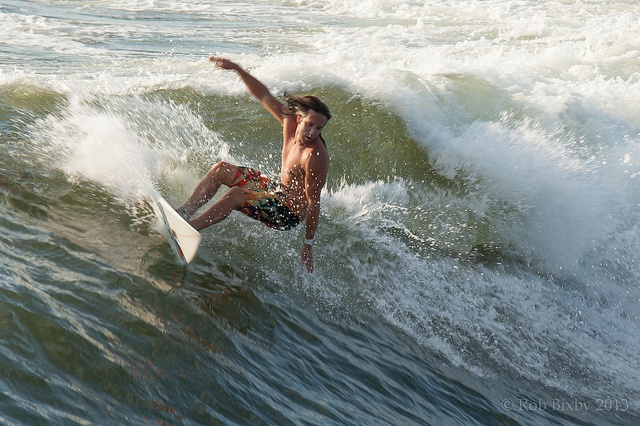Describe the objects in this image and their specific colors. I can see people in lightgray, maroon, black, and gray tones and surfboard in lightgray, darkgray, and gray tones in this image. 